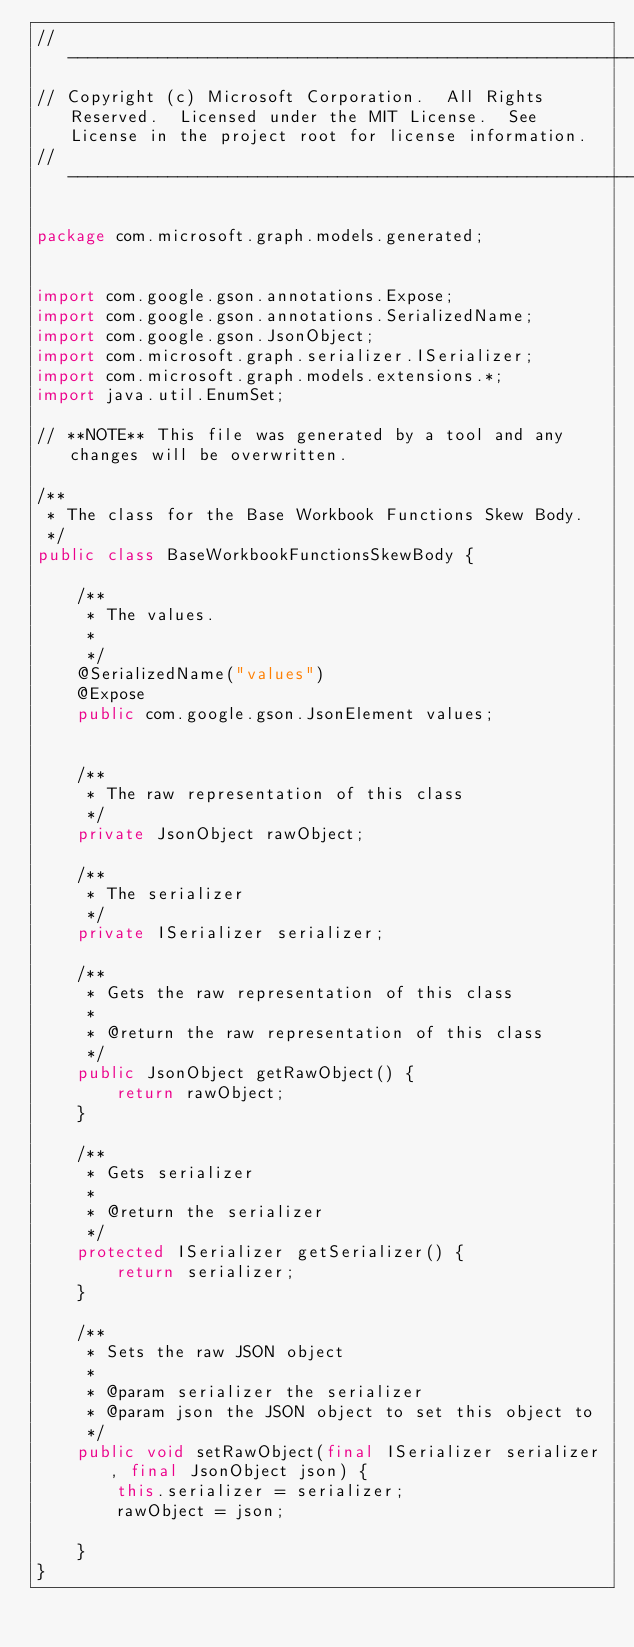Convert code to text. <code><loc_0><loc_0><loc_500><loc_500><_Java_>// ------------------------------------------------------------------------------
// Copyright (c) Microsoft Corporation.  All Rights Reserved.  Licensed under the MIT License.  See License in the project root for license information.
// ------------------------------------------------------------------------------

package com.microsoft.graph.models.generated;


import com.google.gson.annotations.Expose;
import com.google.gson.annotations.SerializedName;
import com.google.gson.JsonObject;
import com.microsoft.graph.serializer.ISerializer;
import com.microsoft.graph.models.extensions.*;
import java.util.EnumSet;

// **NOTE** This file was generated by a tool and any changes will be overwritten.

/**
 * The class for the Base Workbook Functions Skew Body.
 */
public class BaseWorkbookFunctionsSkewBody {

    /**
     * The values.
     * 
     */
    @SerializedName("values")
    @Expose
    public com.google.gson.JsonElement values;


    /**
     * The raw representation of this class
     */
    private JsonObject rawObject;

    /**
     * The serializer
     */
    private ISerializer serializer;

    /**
     * Gets the raw representation of this class
     *
     * @return the raw representation of this class
     */
    public JsonObject getRawObject() {
        return rawObject;
    }

    /**
     * Gets serializer
     *
     * @return the serializer
     */
    protected ISerializer getSerializer() {
        return serializer;
    }

    /**
     * Sets the raw JSON object
     *
     * @param serializer the serializer
     * @param json the JSON object to set this object to
     */
    public void setRawObject(final ISerializer serializer, final JsonObject json) {
        this.serializer = serializer;
        rawObject = json;

    }
}
</code> 